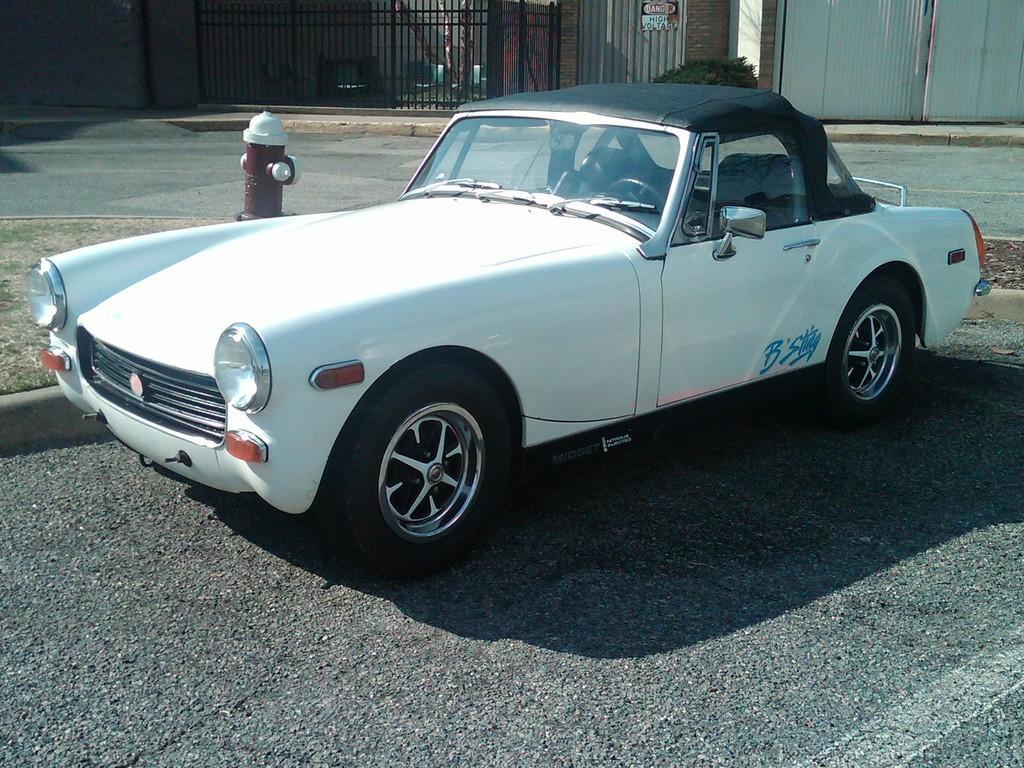Describe this image in one or two sentences. In this image we can see a motor vehicle on the road, hydrant, bushes, buildings and grills. 